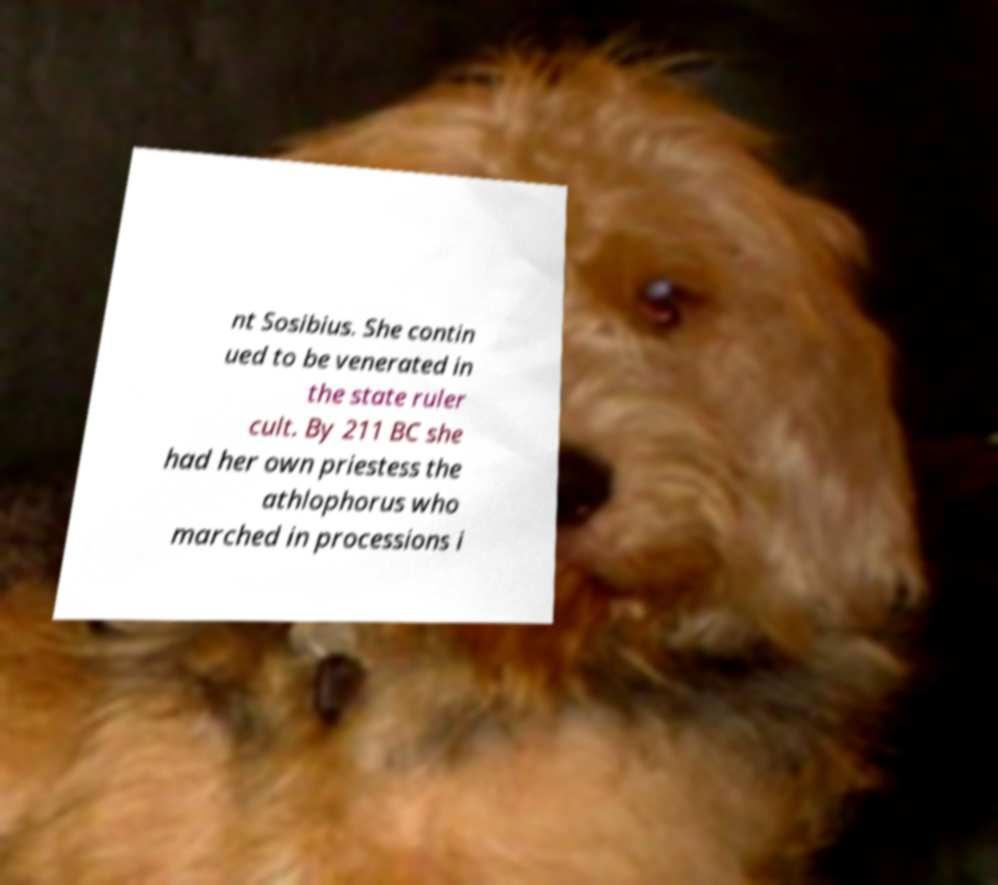I need the written content from this picture converted into text. Can you do that? nt Sosibius. She contin ued to be venerated in the state ruler cult. By 211 BC she had her own priestess the athlophorus who marched in processions i 